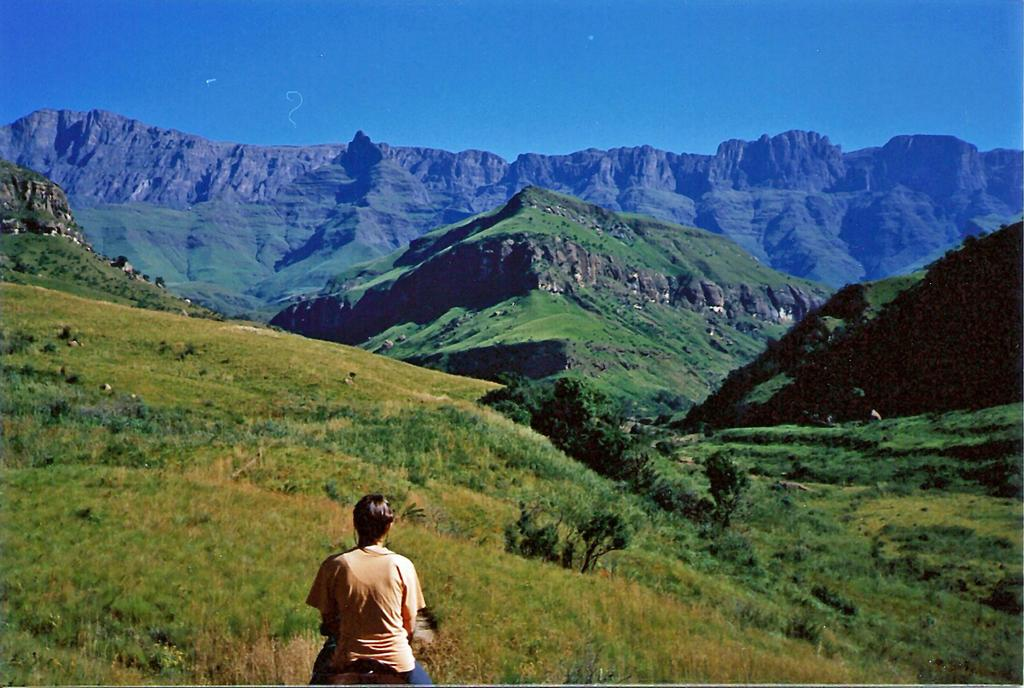What can be seen in the sky in the image? The sky is visible in the image. What type of natural features are present in the image? There are hills, trees, plants, and grass visible in the image. Can you describe the person in the image? There is a person in the image, but no specific details about their appearance or actions are provided. What type of fish can be seen swimming in the image? There is no fish present in the image; it features a sky, hills, trees, plants, grass, and a person. 